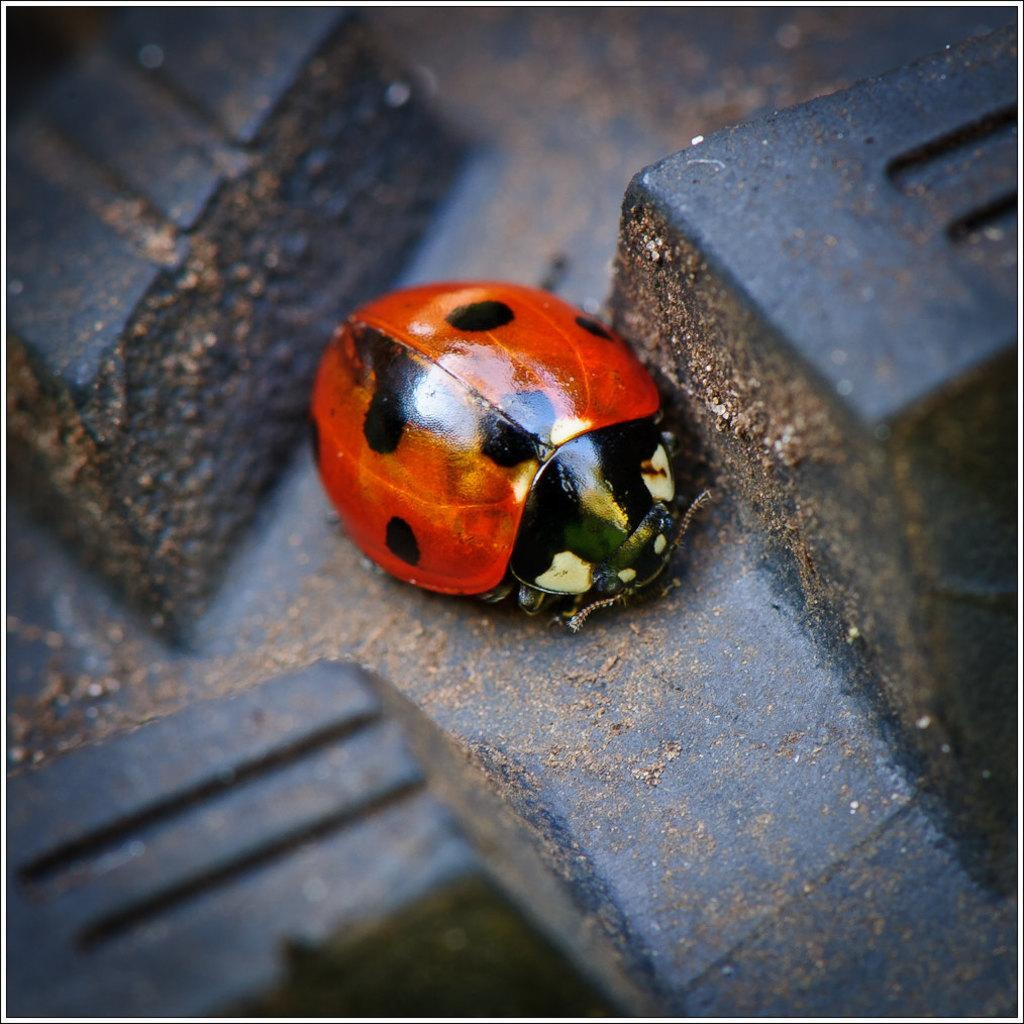What type of creature is in the image? There is an insect in the image. Where is the insect situated? The insect is on a surface. Can you describe the insect's position in the image? The insect is located in the center of the image. What is the weight of the yam on the stage in the image? There is no yam or stage present in the image; it only features an insect on a surface. 